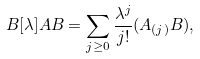<formula> <loc_0><loc_0><loc_500><loc_500>\L B [ \lambda ] { A } { B } = \sum _ { j \geq 0 } \frac { \lambda ^ { j } } { j ! } ( A _ { ( j ) } B ) ,</formula> 